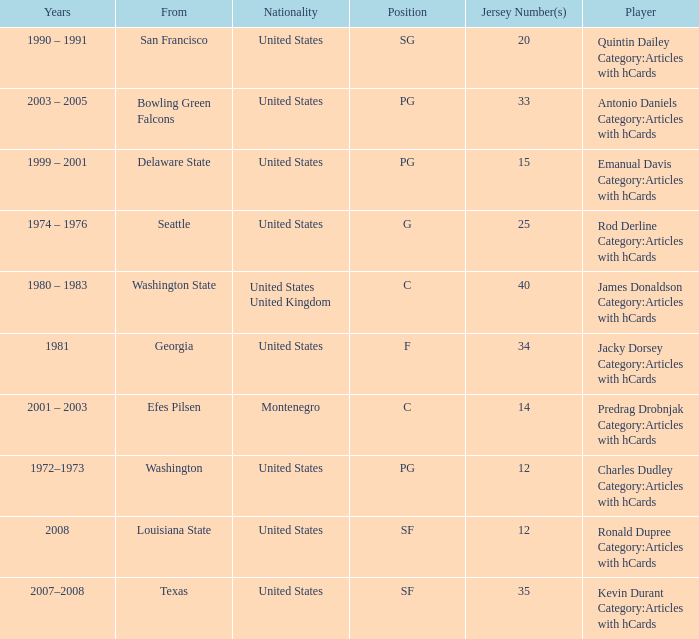What is the lowest jersey number of a player from louisiana state? 12.0. 